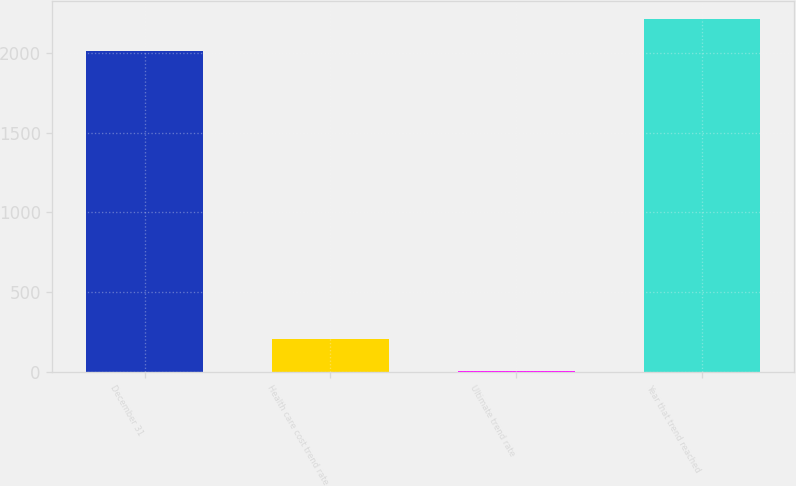<chart> <loc_0><loc_0><loc_500><loc_500><bar_chart><fcel>December 31<fcel>Health care cost trend rate<fcel>Ultimate trend rate<fcel>Year that trend reached<nl><fcel>2015<fcel>206.6<fcel>5<fcel>2216.6<nl></chart> 